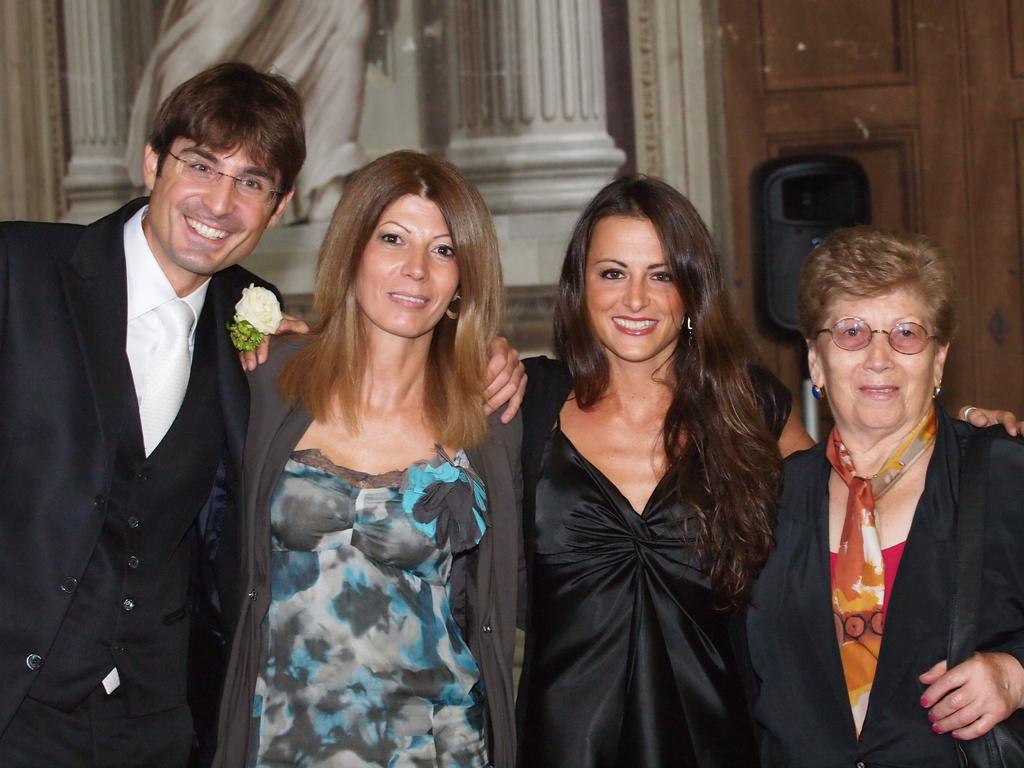How many people are in the image? There are four people in the image. What are the people doing in the image? The people are smiling and standing. What can be seen in the background of the image? There are doors and some objects visible in the background. How many wings can be seen on the building in the image? There is no building present in the image, so it is not possible to determine the number of wings. 